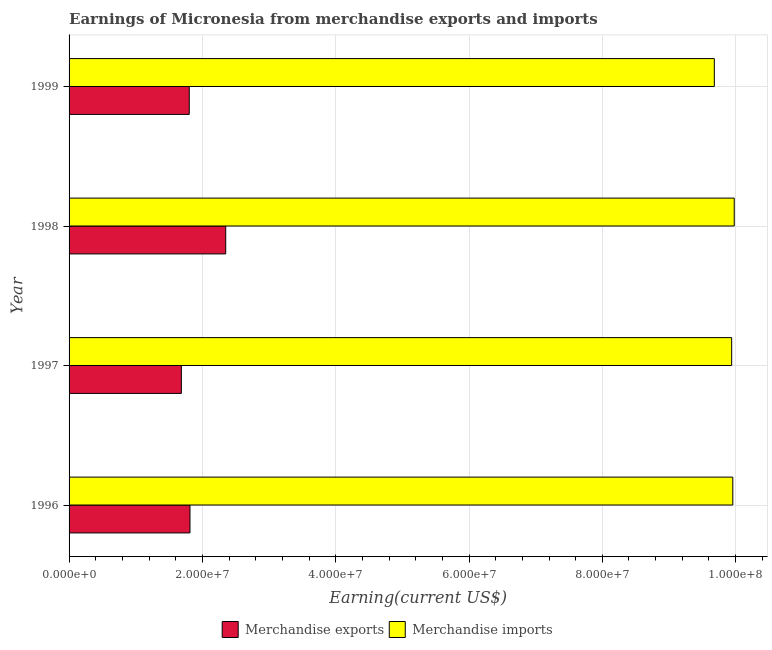How many different coloured bars are there?
Keep it short and to the point. 2. Are the number of bars per tick equal to the number of legend labels?
Your response must be concise. Yes. Are the number of bars on each tick of the Y-axis equal?
Your answer should be compact. Yes. How many bars are there on the 3rd tick from the top?
Keep it short and to the point. 2. How many bars are there on the 3rd tick from the bottom?
Offer a terse response. 2. What is the label of the 2nd group of bars from the top?
Give a very brief answer. 1998. In how many cases, is the number of bars for a given year not equal to the number of legend labels?
Your answer should be very brief. 0. What is the earnings from merchandise imports in 1996?
Provide a short and direct response. 9.96e+07. Across all years, what is the maximum earnings from merchandise imports?
Provide a succinct answer. 9.98e+07. Across all years, what is the minimum earnings from merchandise exports?
Provide a succinct answer. 1.68e+07. In which year was the earnings from merchandise imports maximum?
Provide a short and direct response. 1998. What is the total earnings from merchandise imports in the graph?
Keep it short and to the point. 3.96e+08. What is the difference between the earnings from merchandise exports in 1998 and that in 1999?
Offer a terse response. 5.47e+06. What is the difference between the earnings from merchandise imports in 1998 and the earnings from merchandise exports in 1996?
Your answer should be very brief. 8.17e+07. What is the average earnings from merchandise imports per year?
Your answer should be compact. 9.89e+07. In the year 1999, what is the difference between the earnings from merchandise imports and earnings from merchandise exports?
Your response must be concise. 7.88e+07. What is the ratio of the earnings from merchandise exports in 1996 to that in 1998?
Offer a terse response. 0.77. Is the earnings from merchandise imports in 1996 less than that in 1999?
Give a very brief answer. No. Is the difference between the earnings from merchandise imports in 1998 and 1999 greater than the difference between the earnings from merchandise exports in 1998 and 1999?
Make the answer very short. No. What is the difference between the highest and the second highest earnings from merchandise imports?
Your response must be concise. 2.13e+05. What is the difference between the highest and the lowest earnings from merchandise imports?
Make the answer very short. 2.99e+06. In how many years, is the earnings from merchandise imports greater than the average earnings from merchandise imports taken over all years?
Provide a short and direct response. 3. How many bars are there?
Give a very brief answer. 8. Are all the bars in the graph horizontal?
Make the answer very short. Yes. How many years are there in the graph?
Your answer should be very brief. 4. Are the values on the major ticks of X-axis written in scientific E-notation?
Offer a terse response. Yes. How are the legend labels stacked?
Ensure brevity in your answer.  Horizontal. What is the title of the graph?
Offer a very short reply. Earnings of Micronesia from merchandise exports and imports. What is the label or title of the X-axis?
Ensure brevity in your answer.  Earning(current US$). What is the Earning(current US$) of Merchandise exports in 1996?
Provide a short and direct response. 1.81e+07. What is the Earning(current US$) of Merchandise imports in 1996?
Ensure brevity in your answer.  9.96e+07. What is the Earning(current US$) of Merchandise exports in 1997?
Give a very brief answer. 1.68e+07. What is the Earning(current US$) in Merchandise imports in 1997?
Make the answer very short. 9.94e+07. What is the Earning(current US$) of Merchandise exports in 1998?
Your response must be concise. 2.35e+07. What is the Earning(current US$) of Merchandise imports in 1998?
Keep it short and to the point. 9.98e+07. What is the Earning(current US$) in Merchandise exports in 1999?
Give a very brief answer. 1.80e+07. What is the Earning(current US$) in Merchandise imports in 1999?
Your answer should be very brief. 9.68e+07. Across all years, what is the maximum Earning(current US$) of Merchandise exports?
Your answer should be very brief. 2.35e+07. Across all years, what is the maximum Earning(current US$) of Merchandise imports?
Your answer should be very brief. 9.98e+07. Across all years, what is the minimum Earning(current US$) of Merchandise exports?
Offer a very short reply. 1.68e+07. Across all years, what is the minimum Earning(current US$) of Merchandise imports?
Provide a short and direct response. 9.68e+07. What is the total Earning(current US$) of Merchandise exports in the graph?
Provide a short and direct response. 7.65e+07. What is the total Earning(current US$) of Merchandise imports in the graph?
Provide a succinct answer. 3.96e+08. What is the difference between the Earning(current US$) of Merchandise exports in 1996 and that in 1997?
Offer a very short reply. 1.29e+06. What is the difference between the Earning(current US$) of Merchandise imports in 1996 and that in 1997?
Your answer should be compact. 1.72e+05. What is the difference between the Earning(current US$) in Merchandise exports in 1996 and that in 1998?
Offer a terse response. -5.36e+06. What is the difference between the Earning(current US$) of Merchandise imports in 1996 and that in 1998?
Your answer should be very brief. -2.13e+05. What is the difference between the Earning(current US$) of Merchandise exports in 1996 and that in 1999?
Your response must be concise. 1.08e+05. What is the difference between the Earning(current US$) in Merchandise imports in 1996 and that in 1999?
Give a very brief answer. 2.77e+06. What is the difference between the Earning(current US$) in Merchandise exports in 1997 and that in 1998?
Give a very brief answer. -6.66e+06. What is the difference between the Earning(current US$) in Merchandise imports in 1997 and that in 1998?
Your response must be concise. -3.85e+05. What is the difference between the Earning(current US$) of Merchandise exports in 1997 and that in 1999?
Keep it short and to the point. -1.18e+06. What is the difference between the Earning(current US$) of Merchandise imports in 1997 and that in 1999?
Your answer should be very brief. 2.60e+06. What is the difference between the Earning(current US$) in Merchandise exports in 1998 and that in 1999?
Your answer should be compact. 5.47e+06. What is the difference between the Earning(current US$) of Merchandise imports in 1998 and that in 1999?
Your answer should be compact. 2.99e+06. What is the difference between the Earning(current US$) in Merchandise exports in 1996 and the Earning(current US$) in Merchandise imports in 1997?
Offer a very short reply. -8.13e+07. What is the difference between the Earning(current US$) in Merchandise exports in 1996 and the Earning(current US$) in Merchandise imports in 1998?
Your answer should be very brief. -8.17e+07. What is the difference between the Earning(current US$) in Merchandise exports in 1996 and the Earning(current US$) in Merchandise imports in 1999?
Make the answer very short. -7.87e+07. What is the difference between the Earning(current US$) of Merchandise exports in 1997 and the Earning(current US$) of Merchandise imports in 1998?
Make the answer very short. -8.29e+07. What is the difference between the Earning(current US$) of Merchandise exports in 1997 and the Earning(current US$) of Merchandise imports in 1999?
Ensure brevity in your answer.  -8.00e+07. What is the difference between the Earning(current US$) of Merchandise exports in 1998 and the Earning(current US$) of Merchandise imports in 1999?
Provide a succinct answer. -7.33e+07. What is the average Earning(current US$) in Merchandise exports per year?
Your answer should be compact. 1.91e+07. What is the average Earning(current US$) in Merchandise imports per year?
Provide a short and direct response. 9.89e+07. In the year 1996, what is the difference between the Earning(current US$) in Merchandise exports and Earning(current US$) in Merchandise imports?
Offer a terse response. -8.14e+07. In the year 1997, what is the difference between the Earning(current US$) in Merchandise exports and Earning(current US$) in Merchandise imports?
Your answer should be compact. -8.26e+07. In the year 1998, what is the difference between the Earning(current US$) of Merchandise exports and Earning(current US$) of Merchandise imports?
Your response must be concise. -7.63e+07. In the year 1999, what is the difference between the Earning(current US$) of Merchandise exports and Earning(current US$) of Merchandise imports?
Provide a succinct answer. -7.88e+07. What is the ratio of the Earning(current US$) of Merchandise exports in 1996 to that in 1997?
Provide a short and direct response. 1.08. What is the ratio of the Earning(current US$) of Merchandise imports in 1996 to that in 1997?
Give a very brief answer. 1. What is the ratio of the Earning(current US$) in Merchandise exports in 1996 to that in 1998?
Offer a terse response. 0.77. What is the ratio of the Earning(current US$) in Merchandise imports in 1996 to that in 1999?
Offer a terse response. 1.03. What is the ratio of the Earning(current US$) of Merchandise exports in 1997 to that in 1998?
Ensure brevity in your answer.  0.72. What is the ratio of the Earning(current US$) of Merchandise exports in 1997 to that in 1999?
Your answer should be compact. 0.93. What is the ratio of the Earning(current US$) in Merchandise imports in 1997 to that in 1999?
Your answer should be very brief. 1.03. What is the ratio of the Earning(current US$) of Merchandise exports in 1998 to that in 1999?
Your answer should be very brief. 1.3. What is the ratio of the Earning(current US$) of Merchandise imports in 1998 to that in 1999?
Keep it short and to the point. 1.03. What is the difference between the highest and the second highest Earning(current US$) of Merchandise exports?
Your answer should be very brief. 5.36e+06. What is the difference between the highest and the second highest Earning(current US$) in Merchandise imports?
Give a very brief answer. 2.13e+05. What is the difference between the highest and the lowest Earning(current US$) of Merchandise exports?
Keep it short and to the point. 6.66e+06. What is the difference between the highest and the lowest Earning(current US$) in Merchandise imports?
Ensure brevity in your answer.  2.99e+06. 